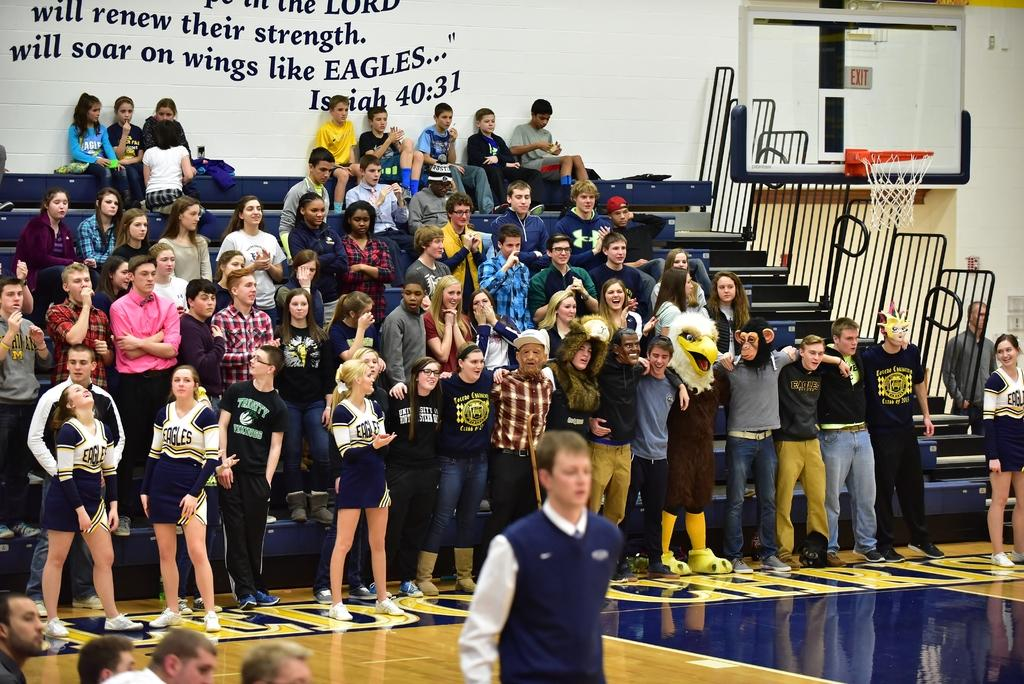<image>
Offer a succinct explanation of the picture presented. The Eagles fans and cheerleaders had a backdrop of the Bible verse Isaiah 40:31. 